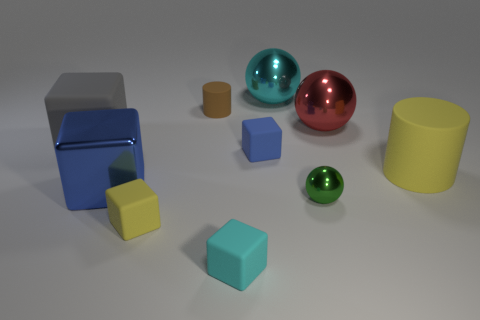Do the green sphere and the large cyan ball have the same material?
Your response must be concise. Yes. What number of green metallic balls have the same size as the red thing?
Your answer should be compact. 0. What is the material of the big blue object?
Keep it short and to the point. Metal. Does the big shiny block have the same color as the tiny rubber block behind the tiny green sphere?
Your response must be concise. Yes. There is a rubber thing that is in front of the tiny metallic ball and to the right of the small yellow block; what is its size?
Give a very brief answer. Small. The other tiny thing that is made of the same material as the red object is what shape?
Offer a very short reply. Sphere. Do the small blue object and the large cyan thing behind the small brown thing have the same material?
Your answer should be compact. No. There is a matte cylinder right of the cyan sphere; is there a yellow cylinder in front of it?
Keep it short and to the point. No. There is a tiny green thing that is the same shape as the cyan shiny object; what is its material?
Your response must be concise. Metal. How many small cyan matte objects are to the right of the big metallic ball behind the red metal object?
Keep it short and to the point. 0. 